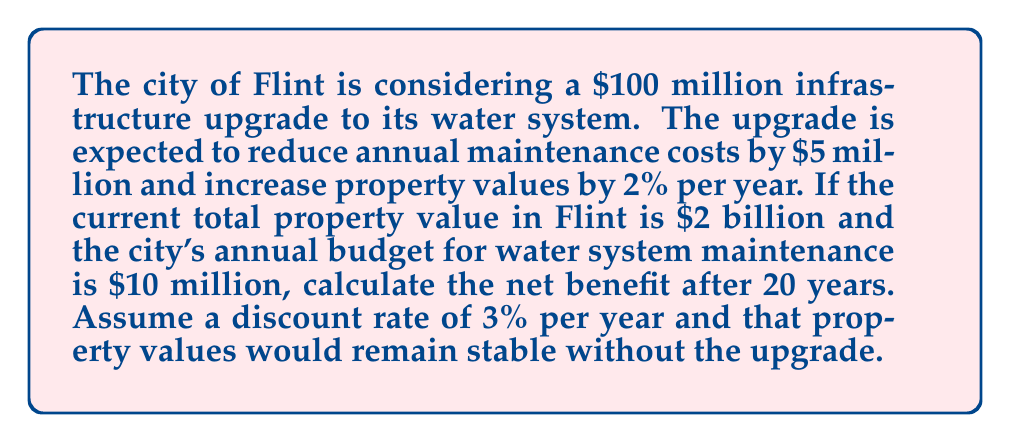Could you help me with this problem? Let's break this down step-by-step:

1) First, let's calculate the present value of cost savings from reduced maintenance:
   Annual savings = $5 million
   Present Value = $\sum_{t=1}^{20} \frac{5,000,000}{(1.03)^t}$
   
   Using the formula for the present value of an annuity:
   $PV = A \cdot \frac{1-(1+r)^{-n}}{r}$
   where A = annual payment, r = discount rate, n = number of years
   
   $PV = 5,000,000 \cdot \frac{1-(1.03)^{-20}}{0.03} = \$74,355,825$

2) Now, let's calculate the increase in property values:
   Without upgrade: $2 billion (constant)
   With upgrade: $2 billion * $(1.02)^t$ for each year t
   
   The present value of the difference after 20 years:
   $PV = \sum_{t=1}^{20} \frac{2,000,000,000 \cdot ((1.02)^t - 1)}{(1.03)^t}$
   
   This sum equals $\$603,717,160$

3) Total benefit = Cost savings + Property value increase
   $\$74,355,825 + \$603,717,160 = \$678,072,985$

4) Net benefit = Total benefit - Cost of upgrade
   $\$678,072,985 - \$100,000,000 = \$578,072,985$
Answer: $\$578,072,985$ 